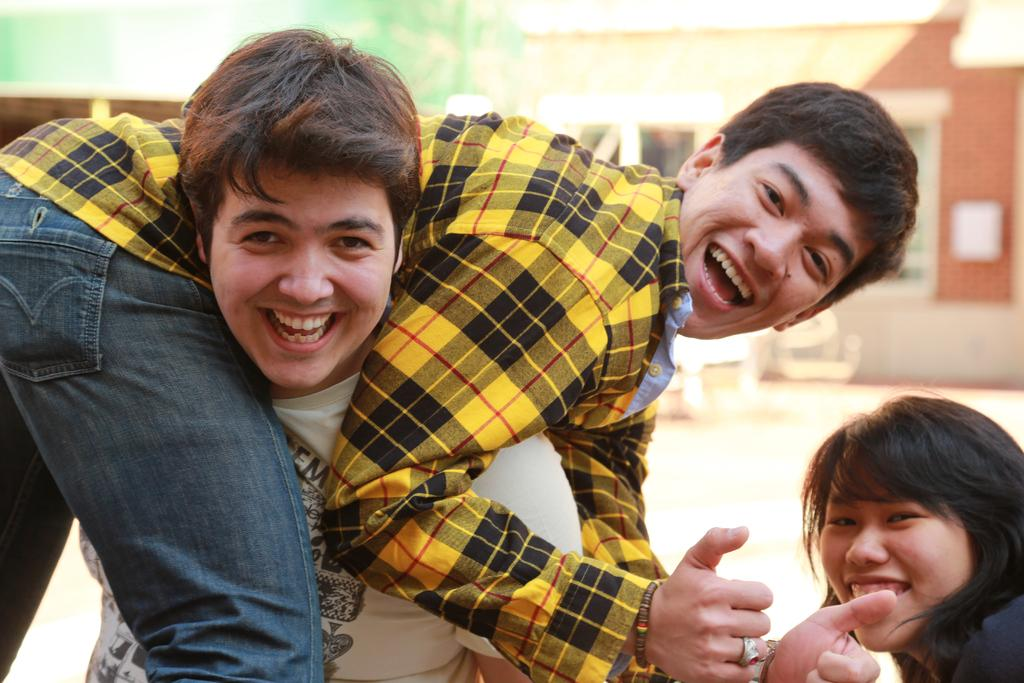How many people are in the image? There are three persons in the image. Can you describe the background of the image? The background of the image is blurred. What is the chance of seeing a bear in the image? There are no bears present in the image, so it is not possible to determine the chance of seeing one. 